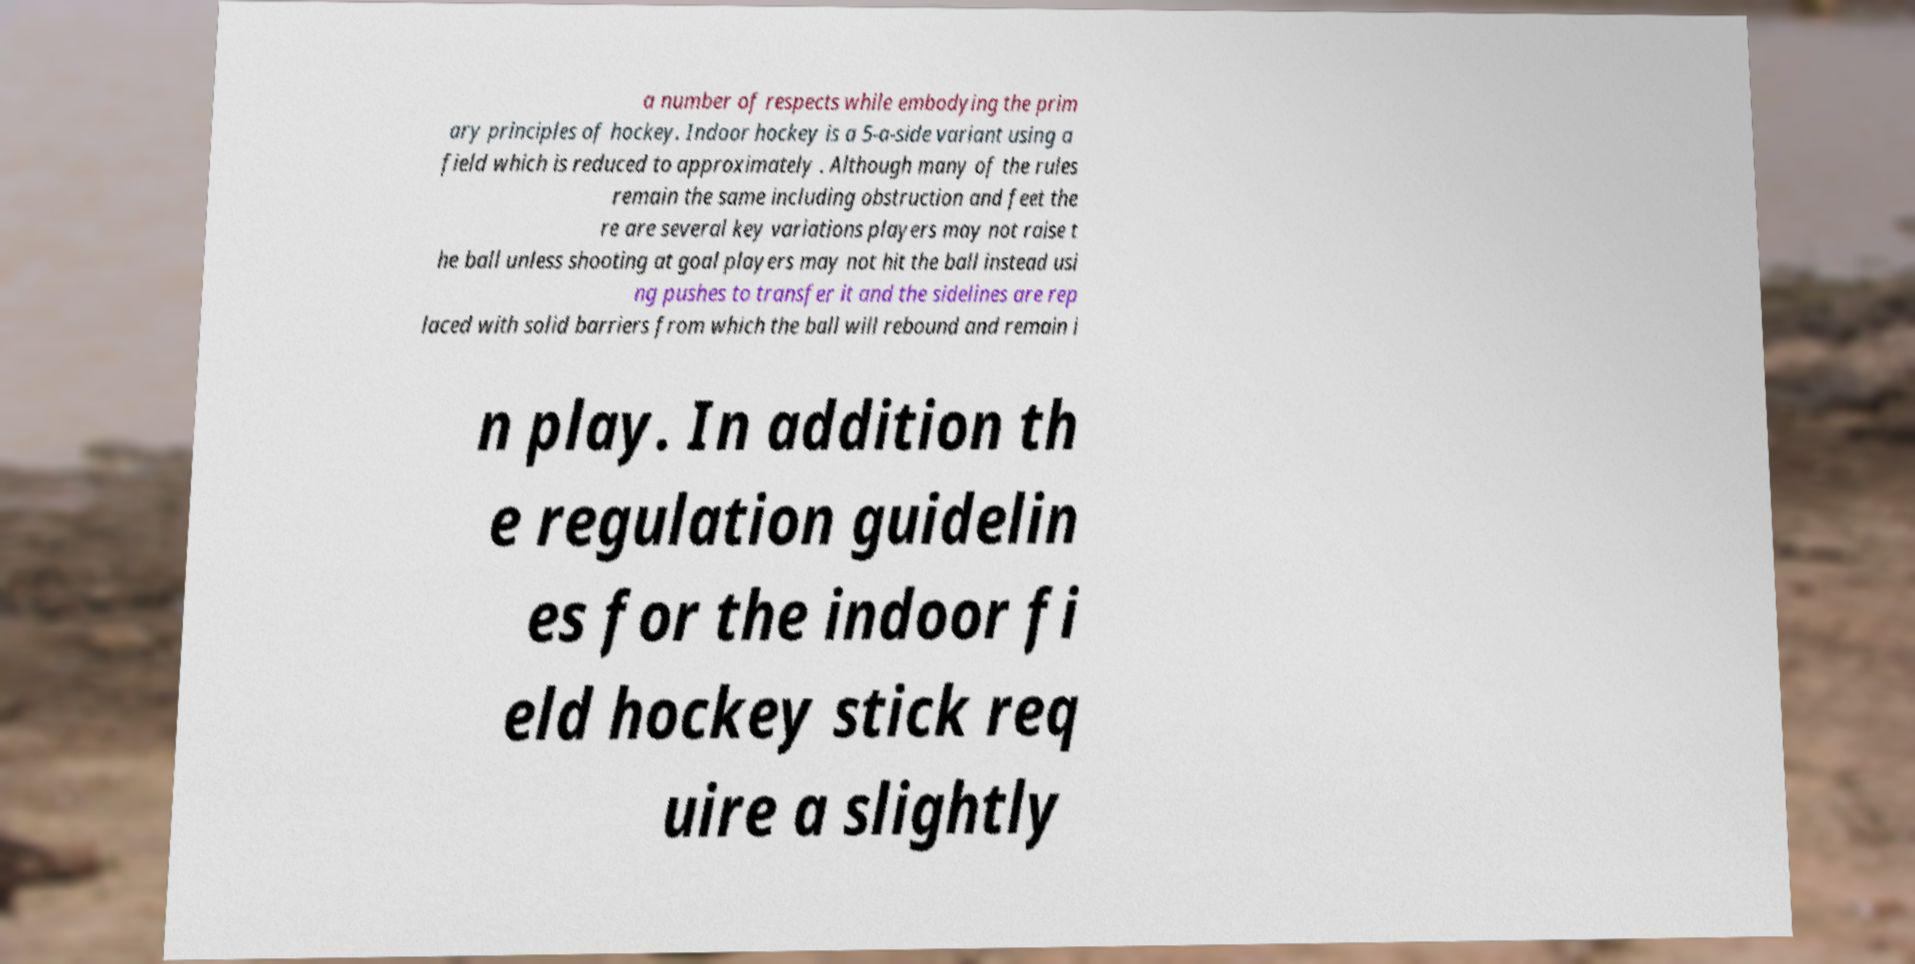For documentation purposes, I need the text within this image transcribed. Could you provide that? a number of respects while embodying the prim ary principles of hockey. Indoor hockey is a 5-a-side variant using a field which is reduced to approximately . Although many of the rules remain the same including obstruction and feet the re are several key variations players may not raise t he ball unless shooting at goal players may not hit the ball instead usi ng pushes to transfer it and the sidelines are rep laced with solid barriers from which the ball will rebound and remain i n play. In addition th e regulation guidelin es for the indoor fi eld hockey stick req uire a slightly 